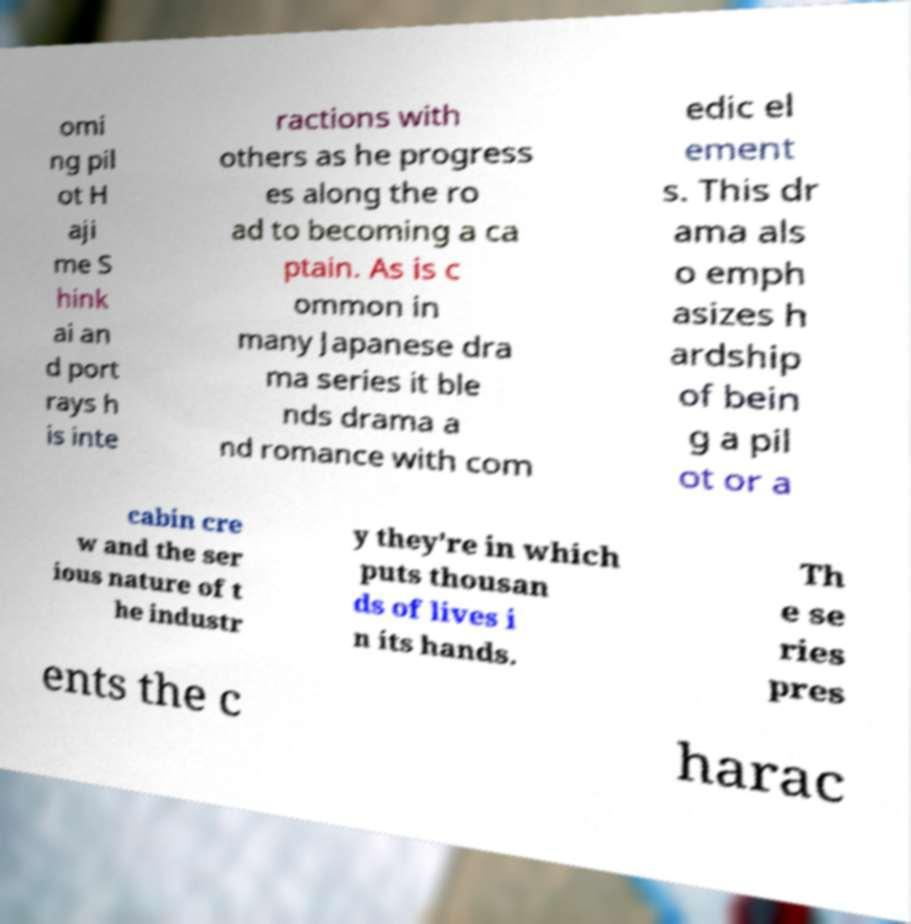I need the written content from this picture converted into text. Can you do that? omi ng pil ot H aji me S hink ai an d port rays h is inte ractions with others as he progress es along the ro ad to becoming a ca ptain. As is c ommon in many Japanese dra ma series it ble nds drama a nd romance with com edic el ement s. This dr ama als o emph asizes h ardship of bein g a pil ot or a cabin cre w and the ser ious nature of t he industr y they're in which puts thousan ds of lives i n its hands. Th e se ries pres ents the c harac 